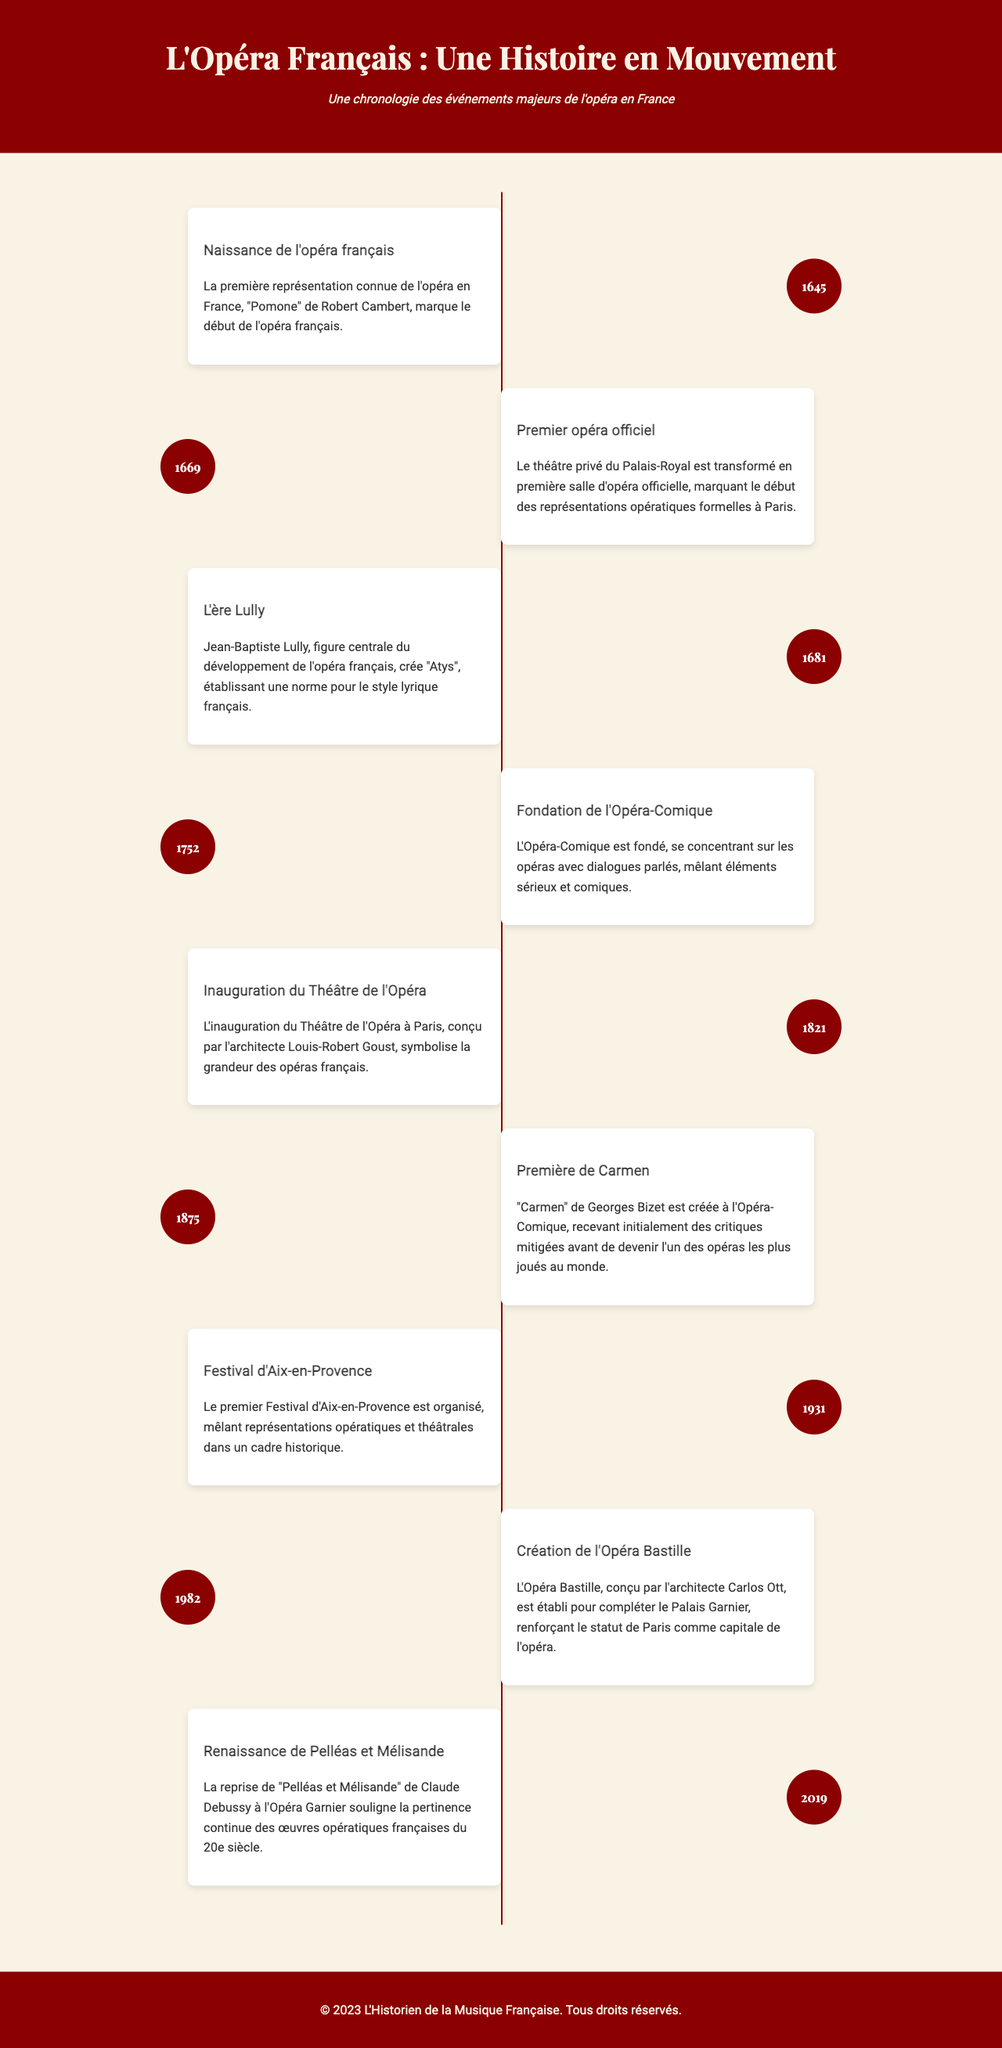What year was "Pomone" performed? "Pomone" was the first known opera in France, marking the beginning of French opera.
Answer: 1645 Who composed "Atys"? "Atys" was created by Jean-Baptiste Lully, a central figure in the development of French opera.
Answer: Jean-Baptiste Lully What significant event happened in 1752? The founding of the Opéra-Comique took place, focusing on operas with spoken dialogues.
Answer: Fondation de l'Opéra-Comique What is the significance of the year 1982? The establishment of the Opéra Bastille occurred in this year, enhancing the opera scene in Paris.
Answer: Création de l'Opéra Bastille Which opera premiered at the Opéra-Comique in 1875? "Carmen" by Georges Bizet had its premiere in this venue, initially receiving mixed reviews.
Answer: Carmen What event was organized in 1931? The first Festival d'Aix-en-Provence was held, combining operatic and theatrical performances.
Answer: Festival d'Aix-en-Provence What architectural feature was completed in 1821? The inauguration of the Théâtre de l'Opéra in Paris symbolized the grandeur of French operas.
Answer: Théâtre de l'Opéra What modern opera was revived at the Opéra Garnier in 2019? The revival of "Pelléas et Mélisande" by Claude Debussy highlighted the relevance of 20th-century French operatic works.
Answer: Pelléas et Mélisande Which architect designed the Opéra Bastille? Carlos Ott was the architect responsible for the design of the Opéra Bastille.
Answer: Carlos Ott 